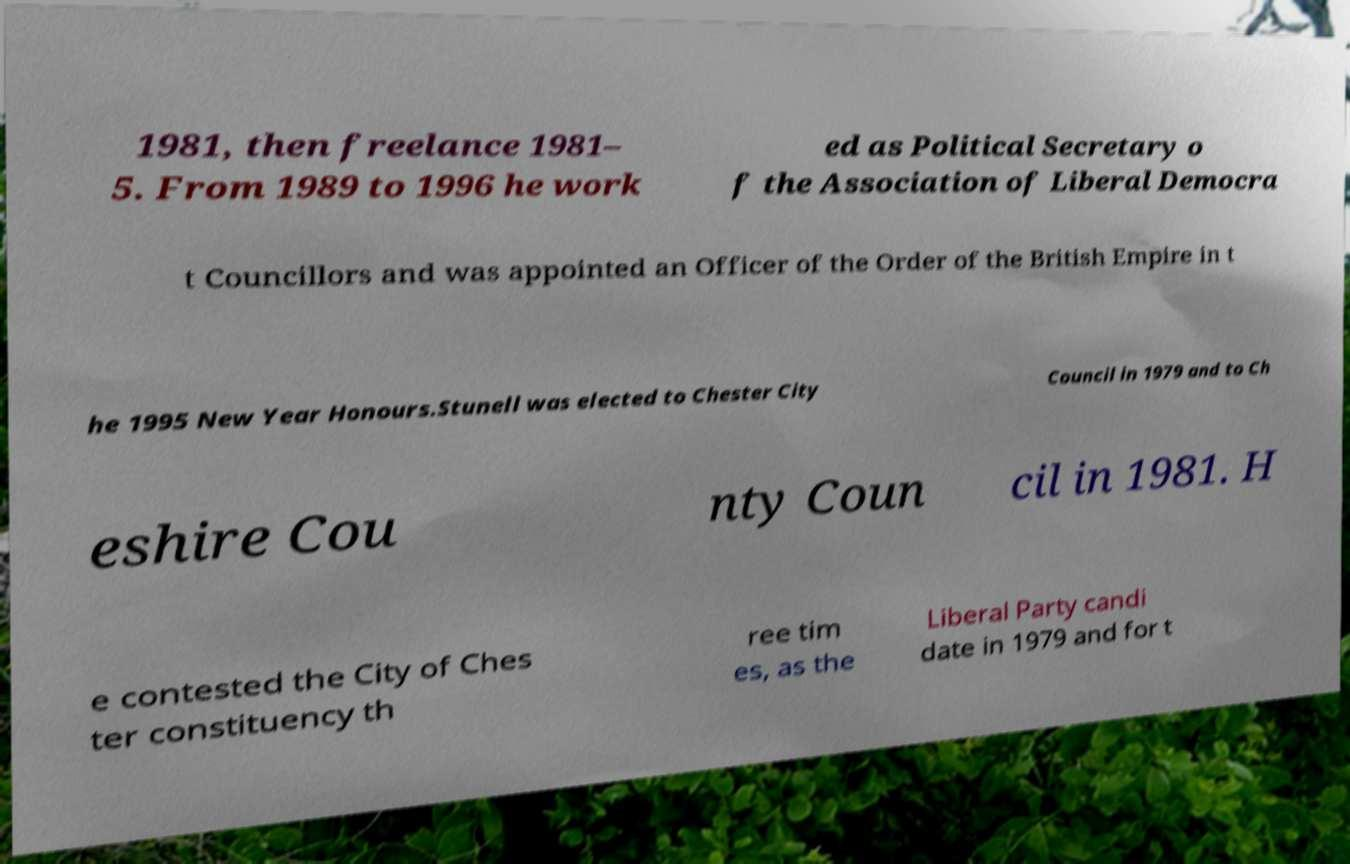What messages or text are displayed in this image? I need them in a readable, typed format. 1981, then freelance 1981– 5. From 1989 to 1996 he work ed as Political Secretary o f the Association of Liberal Democra t Councillors and was appointed an Officer of the Order of the British Empire in t he 1995 New Year Honours.Stunell was elected to Chester City Council in 1979 and to Ch eshire Cou nty Coun cil in 1981. H e contested the City of Ches ter constituency th ree tim es, as the Liberal Party candi date in 1979 and for t 